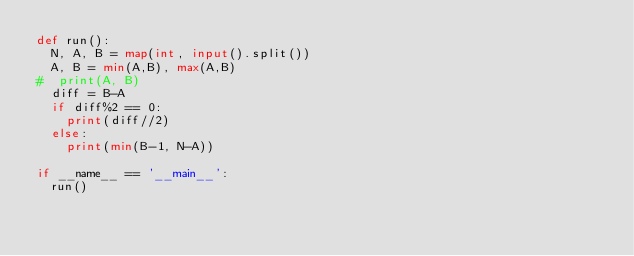Convert code to text. <code><loc_0><loc_0><loc_500><loc_500><_Python_>def run():
  N, A, B = map(int, input().split())
  A, B = min(A,B), max(A,B)
#  print(A, B)
  diff = B-A
  if diff%2 == 0:
    print(diff//2)
  else:
    print(min(B-1, N-A))

if __name__ == '__main__':
  run()</code> 